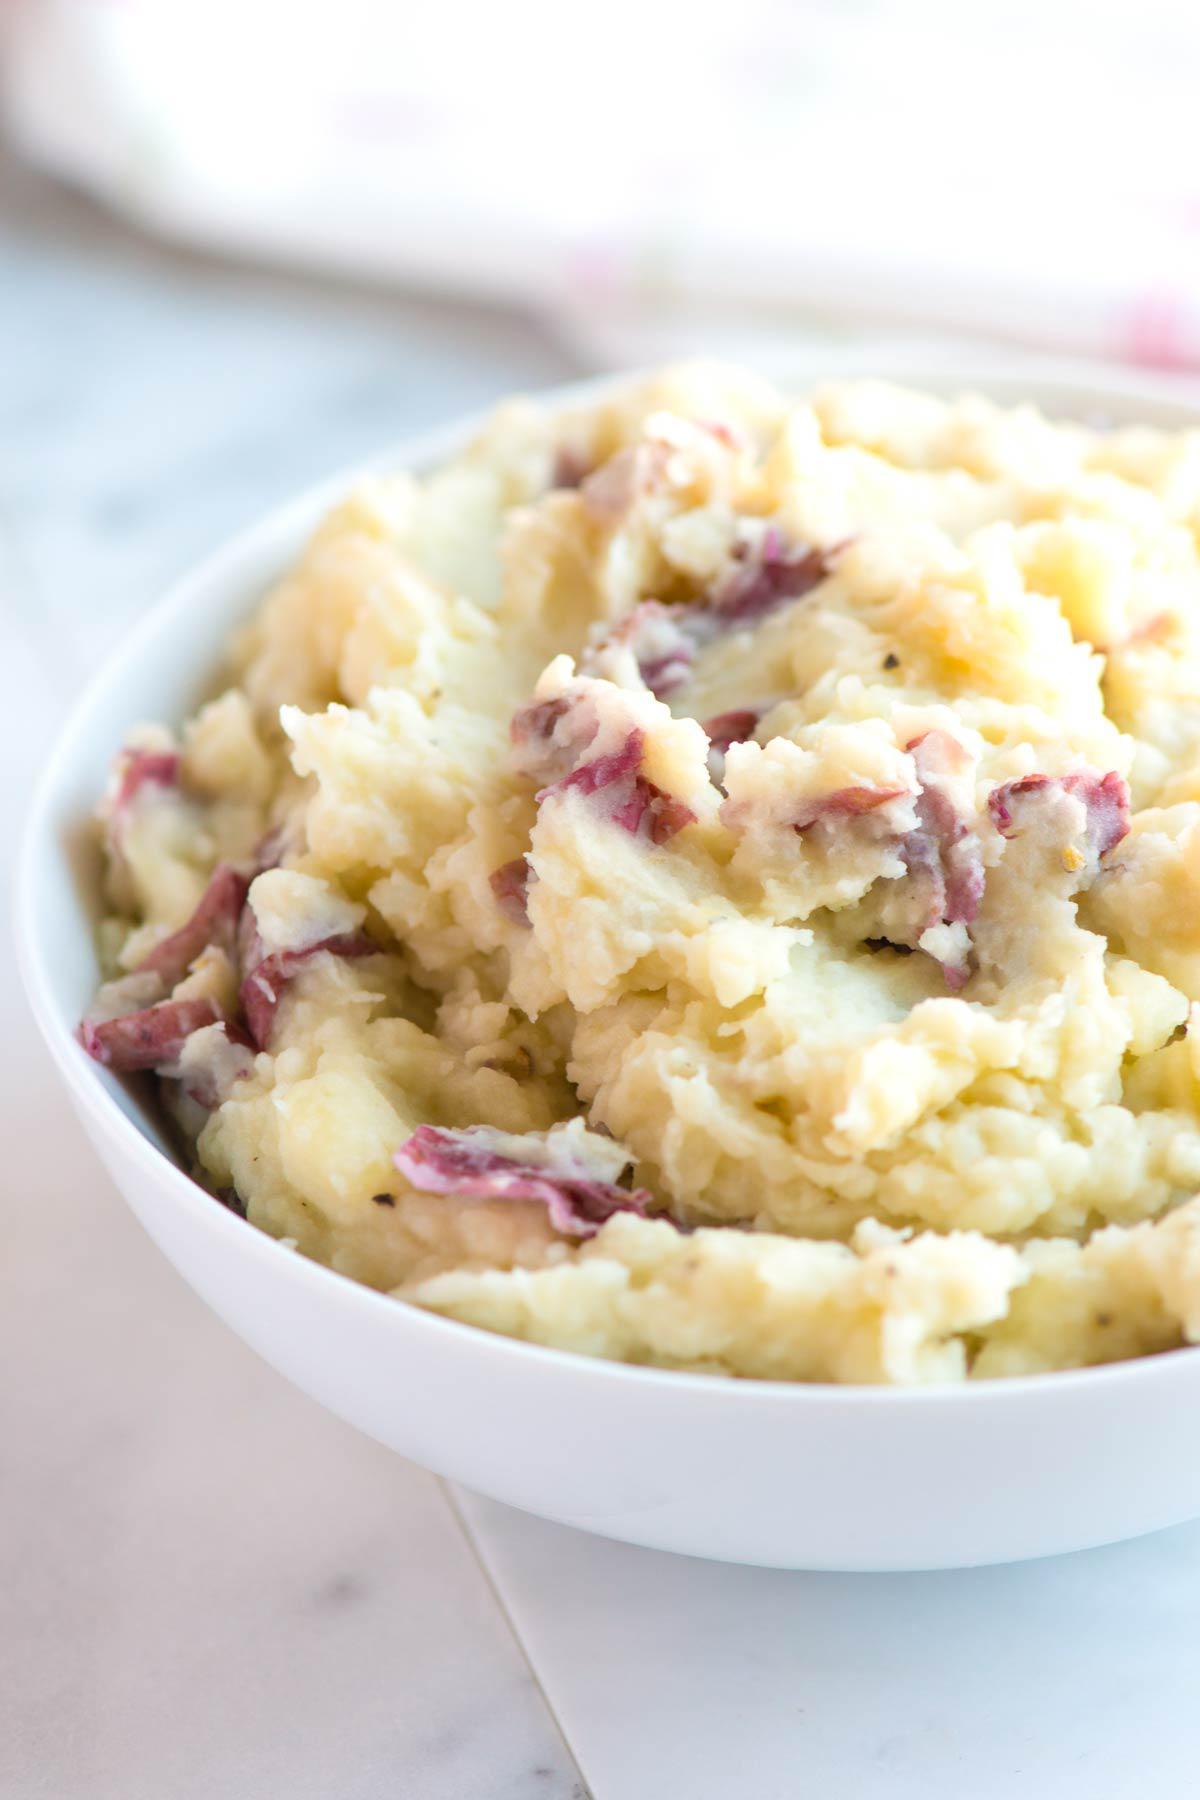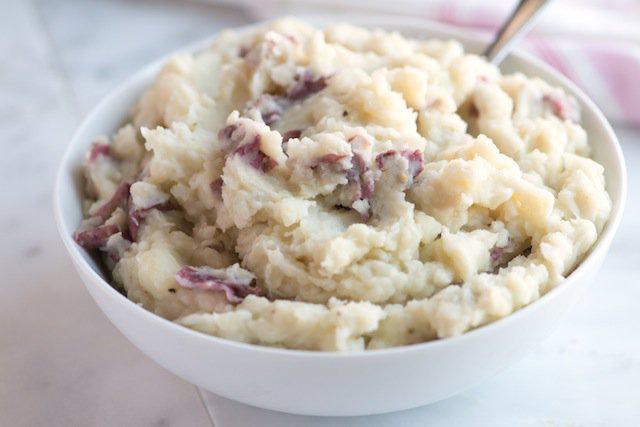The first image is the image on the left, the second image is the image on the right. For the images displayed, is the sentence "Mashed potatoes are in a squared white dish in one image." factually correct? Answer yes or no. No. The first image is the image on the left, the second image is the image on the right. For the images displayed, is the sentence "The potatoes in the image on the left are served in a square shaped bowl." factually correct? Answer yes or no. No. 